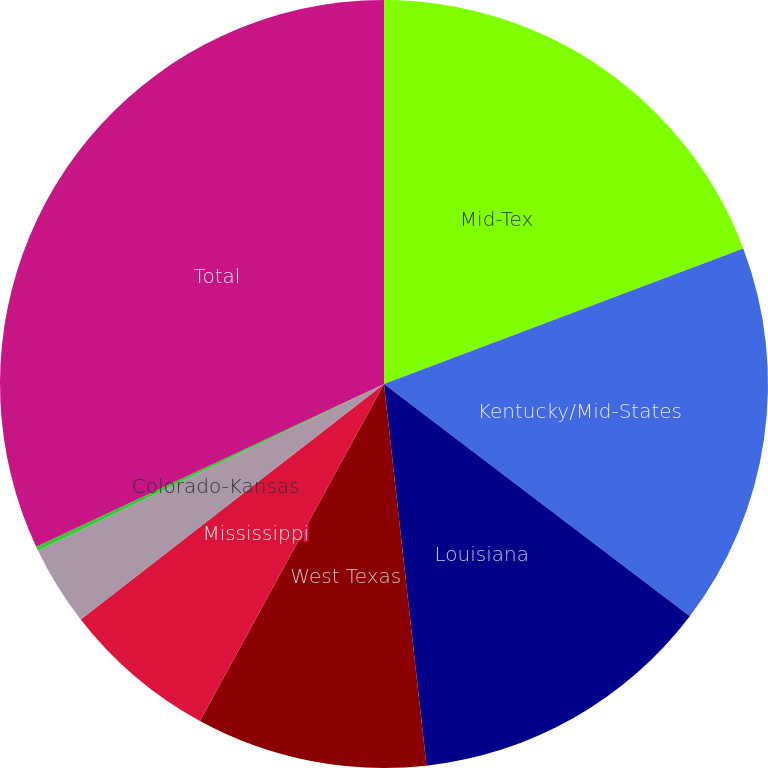Convert chart. <chart><loc_0><loc_0><loc_500><loc_500><pie_chart><fcel>Mid-Tex<fcel>Kentucky/Mid-States<fcel>Louisiana<fcel>West Texas<fcel>Mississippi<fcel>Colorado-Kansas<fcel>Other<fcel>Total<nl><fcel>19.26%<fcel>16.08%<fcel>12.9%<fcel>9.72%<fcel>6.54%<fcel>3.36%<fcel>0.18%<fcel>31.97%<nl></chart> 